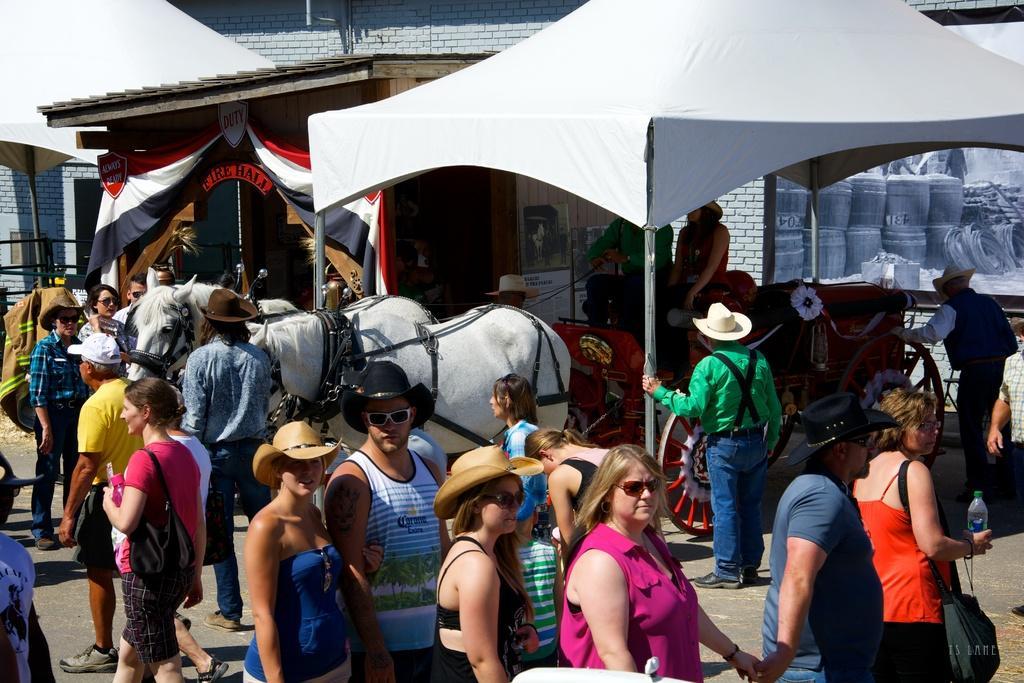Could you give a brief overview of what you see in this image? in this image there is a tent in the middle. Under the tent there are two persons sitting in the horse cart. In the background there is a building. At the bottom there are few people standing on the floor by wearing the hats. On the right side top there is a banner. On the left side there is a flag attached to the wall. 